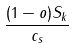Convert formula to latex. <formula><loc_0><loc_0><loc_500><loc_500>\frac { ( 1 - o ) S _ { k } } { c _ { s } }</formula> 